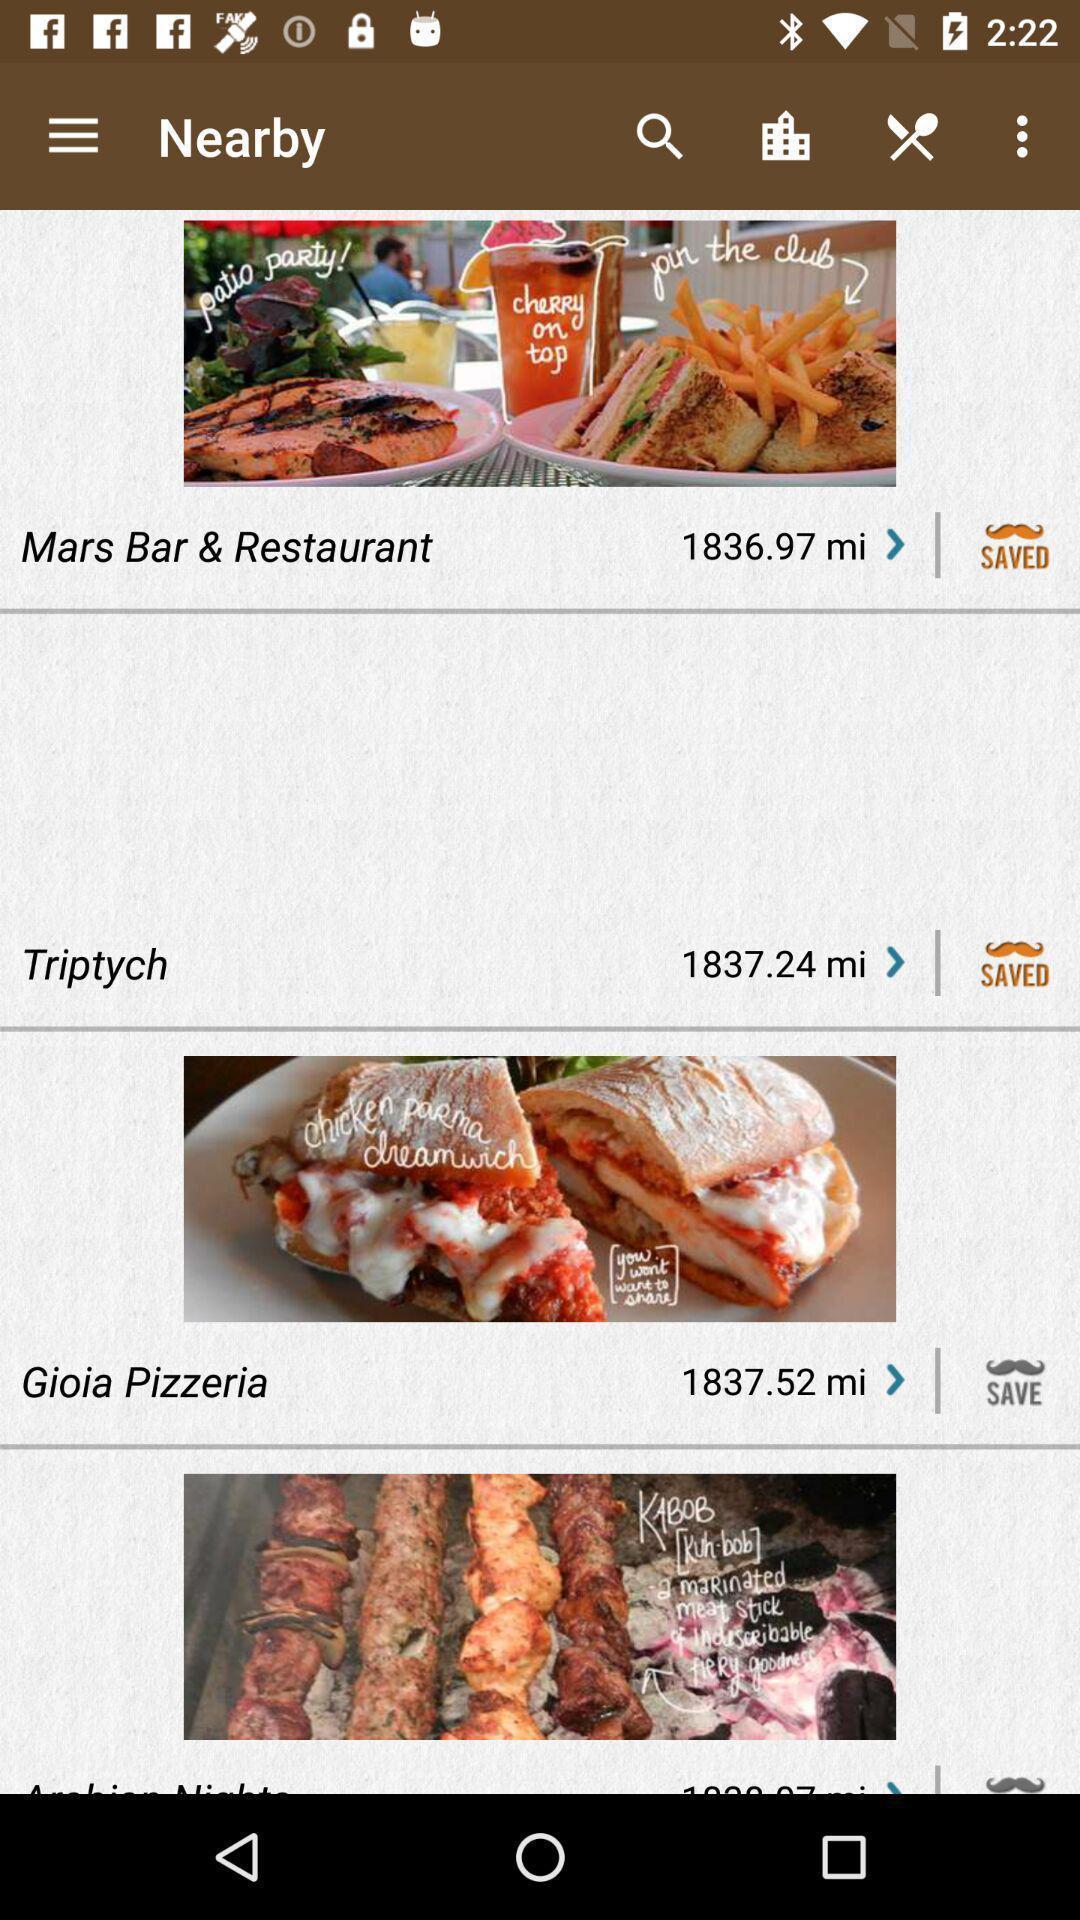Provide a detailed account of this screenshot. Screen displaying of food applications. 